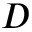Convert formula to latex. <formula><loc_0><loc_0><loc_500><loc_500>D</formula> 